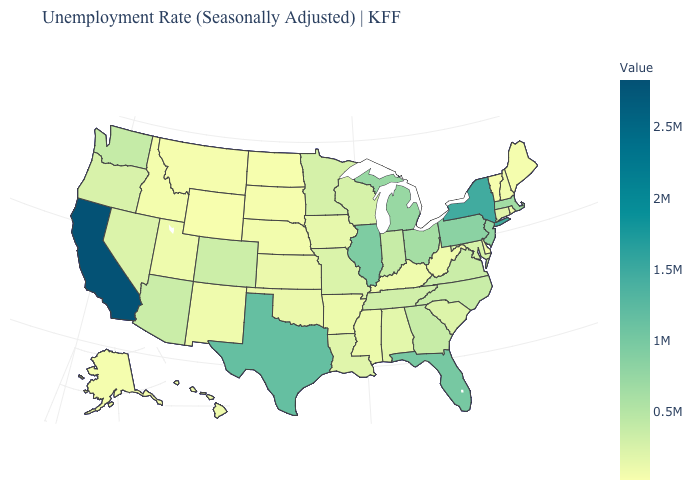Which states have the lowest value in the West?
Be succinct. Wyoming. Is the legend a continuous bar?
Be succinct. Yes. Does Virginia have a higher value than North Dakota?
Be succinct. Yes. Among the states that border California , does Oregon have the highest value?
Write a very short answer. No. Does Wyoming have the lowest value in the USA?
Write a very short answer. Yes. Does New Mexico have a higher value than Washington?
Concise answer only. No. 